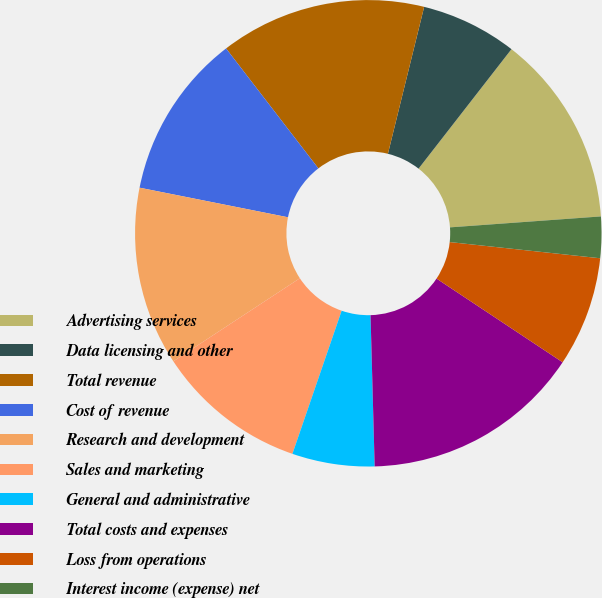Convert chart. <chart><loc_0><loc_0><loc_500><loc_500><pie_chart><fcel>Advertising services<fcel>Data licensing and other<fcel>Total revenue<fcel>Cost of revenue<fcel>Research and development<fcel>Sales and marketing<fcel>General and administrative<fcel>Total costs and expenses<fcel>Loss from operations<fcel>Interest income (expense) net<nl><fcel>13.33%<fcel>6.67%<fcel>14.29%<fcel>11.43%<fcel>12.38%<fcel>10.48%<fcel>5.71%<fcel>15.24%<fcel>7.62%<fcel>2.86%<nl></chart> 